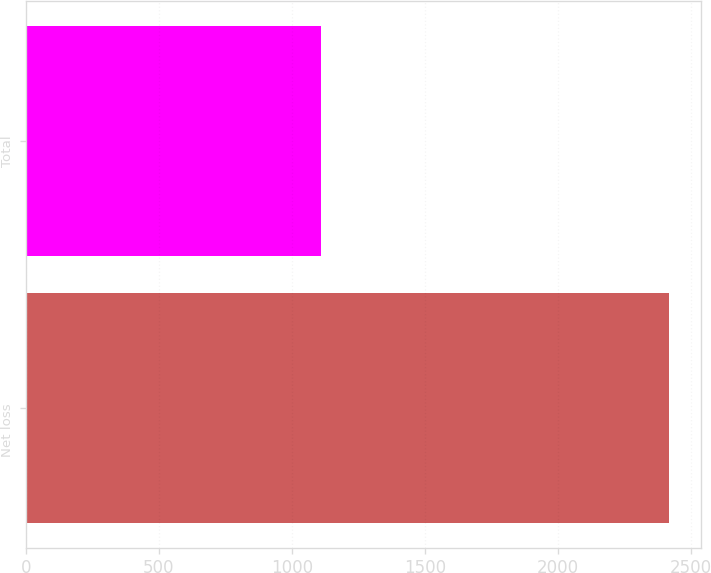<chart> <loc_0><loc_0><loc_500><loc_500><bar_chart><fcel>Net loss<fcel>Total<nl><fcel>2416<fcel>1111<nl></chart> 